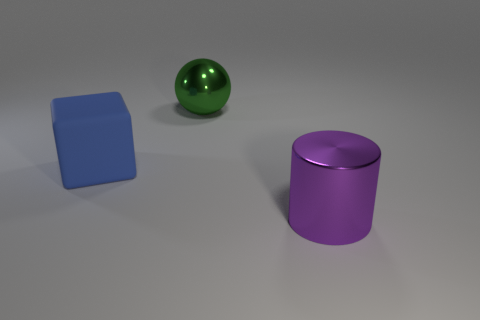What materials appear to be used for the objects in the image? The objects in the image seem to have a smooth and reflective surface, suggesting they could be made of materials like polished plastic or metal with a matte or satin finish. The sheen on the green sphere and purple cylinder indicates they might be reflective, whereas the blue cube has a more diffuse reflection, pointing to a less glossy material. 